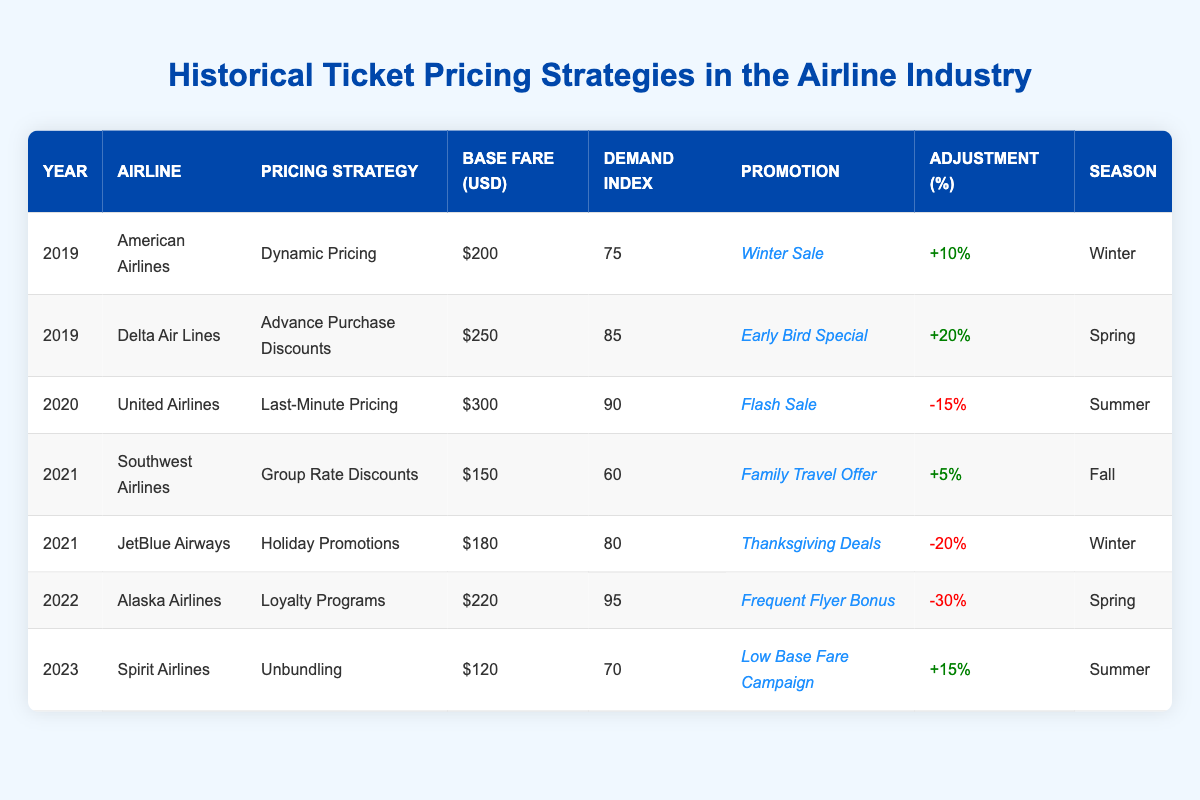What was the base fare for Delta Air Lines in 2019? The table shows the base fare for Delta Air Lines in the year 2019 is listed as $250.
Answer: 250 Which airline implemented 'Dynamic Pricing' in 2019? Referring to the table, American Airlines is the one that used 'Dynamic Pricing' in 2019.
Answer: American Airlines What is the average demand index for the airlines listed in 2021? The demand indices for 2021 are 60 (Southwest Airlines) and 80 (JetBlue Airways). The average is (60 + 80) / 2 = 70.
Answer: 70 Did Alaska Airlines use a pricing strategy that included discounts in 2022? The table states that Alaska Airlines used 'Loyalty Programs' in 2022, which is not a discount strategy. Therefore, the answer is no.
Answer: No What was the adjustment percentage for JetBlue Airways in 2021 and was it positive or negative? The adjustment percentage for JetBlue Airways in 2021 is -20%, which classifies as a negative adjustment.
Answer: Negative What was the highest demand index recorded in the table, and which airline year did it correspond to? The highest demand index is 95 recorded for Alaska Airlines in the year 2022.
Answer: 95, Alaska Airlines, 2022 If we combine the base fares for all airlines in 2019, what is the total? The base fares for 2019 are $200 (American Airlines) and $250 (Delta Air Lines). Adding these gives $200 + $250 = $450.
Answer: 450 Which airline had the lowest base fare in the table, and what was it? The table indicates that Spirit Airlines had the lowest base fare at $120 in 2023.
Answer: Spirit Airlines, 120 How many promotions are targeted towards seasonal trips across the table? The table shows promotions in Winter, Spring, Summer, and Fall, totaling four promotions oriented towards different seasons.
Answer: 4 